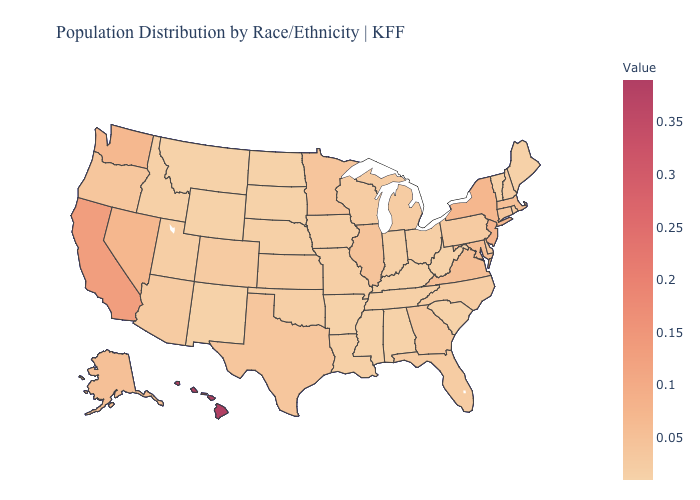Does the map have missing data?
Answer briefly. No. Does Tennessee have a higher value than Nevada?
Answer briefly. No. 